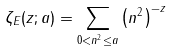Convert formula to latex. <formula><loc_0><loc_0><loc_500><loc_500>\zeta _ { E } ( z ; a ) = \sum _ { 0 < { n } ^ { 2 } \leq a } \left ( { n } ^ { 2 } \right ) ^ { - z }</formula> 